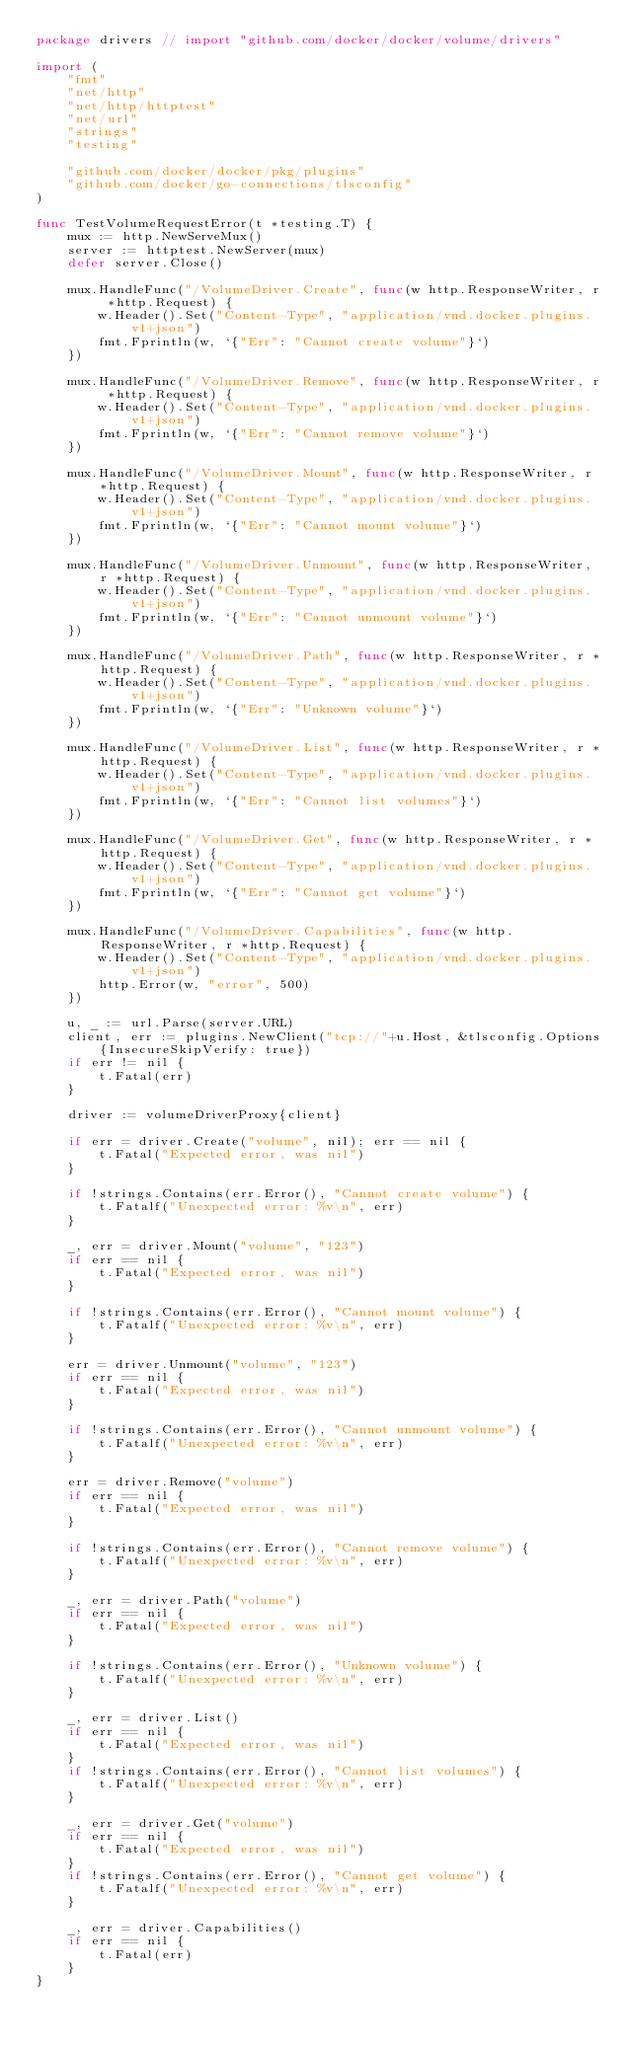<code> <loc_0><loc_0><loc_500><loc_500><_Go_>package drivers // import "github.com/docker/docker/volume/drivers"

import (
	"fmt"
	"net/http"
	"net/http/httptest"
	"net/url"
	"strings"
	"testing"

	"github.com/docker/docker/pkg/plugins"
	"github.com/docker/go-connections/tlsconfig"
)

func TestVolumeRequestError(t *testing.T) {
	mux := http.NewServeMux()
	server := httptest.NewServer(mux)
	defer server.Close()

	mux.HandleFunc("/VolumeDriver.Create", func(w http.ResponseWriter, r *http.Request) {
		w.Header().Set("Content-Type", "application/vnd.docker.plugins.v1+json")
		fmt.Fprintln(w, `{"Err": "Cannot create volume"}`)
	})

	mux.HandleFunc("/VolumeDriver.Remove", func(w http.ResponseWriter, r *http.Request) {
		w.Header().Set("Content-Type", "application/vnd.docker.plugins.v1+json")
		fmt.Fprintln(w, `{"Err": "Cannot remove volume"}`)
	})

	mux.HandleFunc("/VolumeDriver.Mount", func(w http.ResponseWriter, r *http.Request) {
		w.Header().Set("Content-Type", "application/vnd.docker.plugins.v1+json")
		fmt.Fprintln(w, `{"Err": "Cannot mount volume"}`)
	})

	mux.HandleFunc("/VolumeDriver.Unmount", func(w http.ResponseWriter, r *http.Request) {
		w.Header().Set("Content-Type", "application/vnd.docker.plugins.v1+json")
		fmt.Fprintln(w, `{"Err": "Cannot unmount volume"}`)
	})

	mux.HandleFunc("/VolumeDriver.Path", func(w http.ResponseWriter, r *http.Request) {
		w.Header().Set("Content-Type", "application/vnd.docker.plugins.v1+json")
		fmt.Fprintln(w, `{"Err": "Unknown volume"}`)
	})

	mux.HandleFunc("/VolumeDriver.List", func(w http.ResponseWriter, r *http.Request) {
		w.Header().Set("Content-Type", "application/vnd.docker.plugins.v1+json")
		fmt.Fprintln(w, `{"Err": "Cannot list volumes"}`)
	})

	mux.HandleFunc("/VolumeDriver.Get", func(w http.ResponseWriter, r *http.Request) {
		w.Header().Set("Content-Type", "application/vnd.docker.plugins.v1+json")
		fmt.Fprintln(w, `{"Err": "Cannot get volume"}`)
	})

	mux.HandleFunc("/VolumeDriver.Capabilities", func(w http.ResponseWriter, r *http.Request) {
		w.Header().Set("Content-Type", "application/vnd.docker.plugins.v1+json")
		http.Error(w, "error", 500)
	})

	u, _ := url.Parse(server.URL)
	client, err := plugins.NewClient("tcp://"+u.Host, &tlsconfig.Options{InsecureSkipVerify: true})
	if err != nil {
		t.Fatal(err)
	}

	driver := volumeDriverProxy{client}

	if err = driver.Create("volume", nil); err == nil {
		t.Fatal("Expected error, was nil")
	}

	if !strings.Contains(err.Error(), "Cannot create volume") {
		t.Fatalf("Unexpected error: %v\n", err)
	}

	_, err = driver.Mount("volume", "123")
	if err == nil {
		t.Fatal("Expected error, was nil")
	}

	if !strings.Contains(err.Error(), "Cannot mount volume") {
		t.Fatalf("Unexpected error: %v\n", err)
	}

	err = driver.Unmount("volume", "123")
	if err == nil {
		t.Fatal("Expected error, was nil")
	}

	if !strings.Contains(err.Error(), "Cannot unmount volume") {
		t.Fatalf("Unexpected error: %v\n", err)
	}

	err = driver.Remove("volume")
	if err == nil {
		t.Fatal("Expected error, was nil")
	}

	if !strings.Contains(err.Error(), "Cannot remove volume") {
		t.Fatalf("Unexpected error: %v\n", err)
	}

	_, err = driver.Path("volume")
	if err == nil {
		t.Fatal("Expected error, was nil")
	}

	if !strings.Contains(err.Error(), "Unknown volume") {
		t.Fatalf("Unexpected error: %v\n", err)
	}

	_, err = driver.List()
	if err == nil {
		t.Fatal("Expected error, was nil")
	}
	if !strings.Contains(err.Error(), "Cannot list volumes") {
		t.Fatalf("Unexpected error: %v\n", err)
	}

	_, err = driver.Get("volume")
	if err == nil {
		t.Fatal("Expected error, was nil")
	}
	if !strings.Contains(err.Error(), "Cannot get volume") {
		t.Fatalf("Unexpected error: %v\n", err)
	}

	_, err = driver.Capabilities()
	if err == nil {
		t.Fatal(err)
	}
}
</code> 